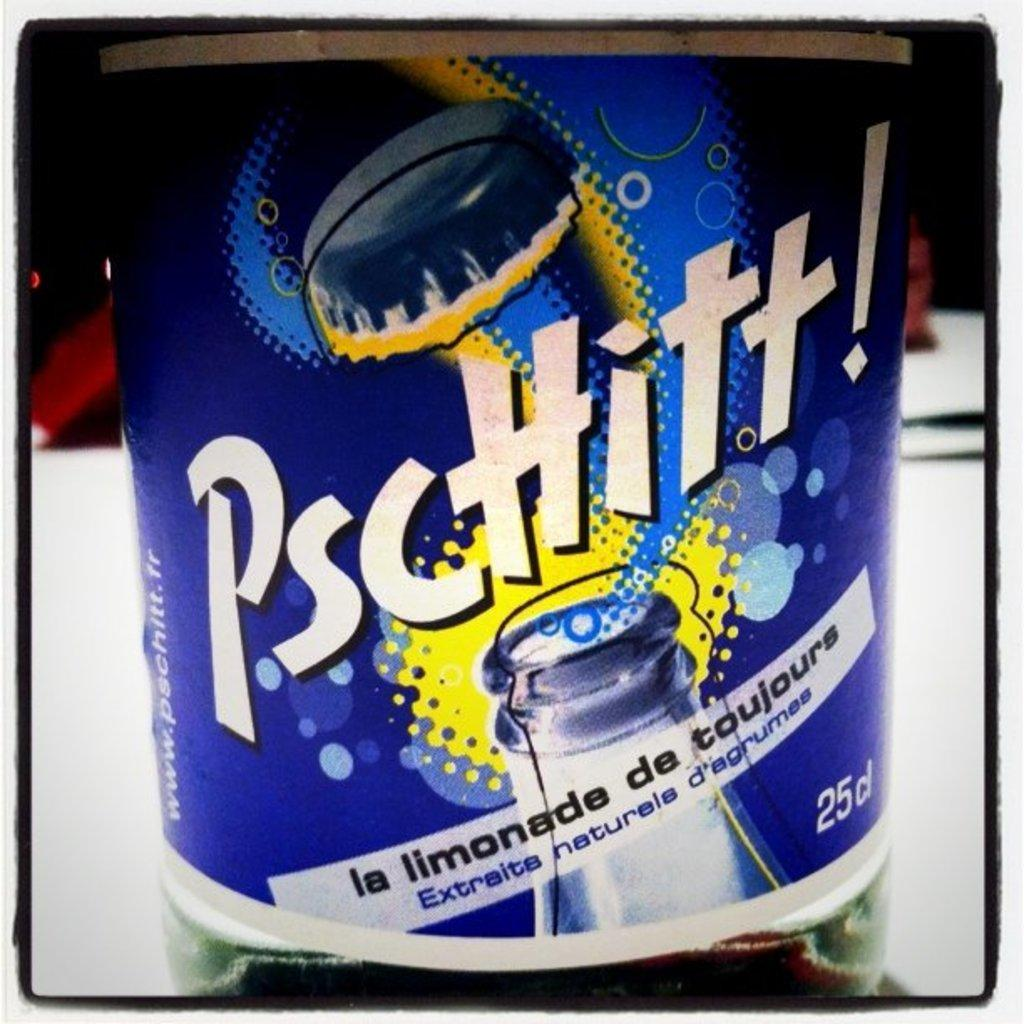<image>
Describe the image concisely. A bottle of La Limonada de toujours by Pschitt! sits on a table 